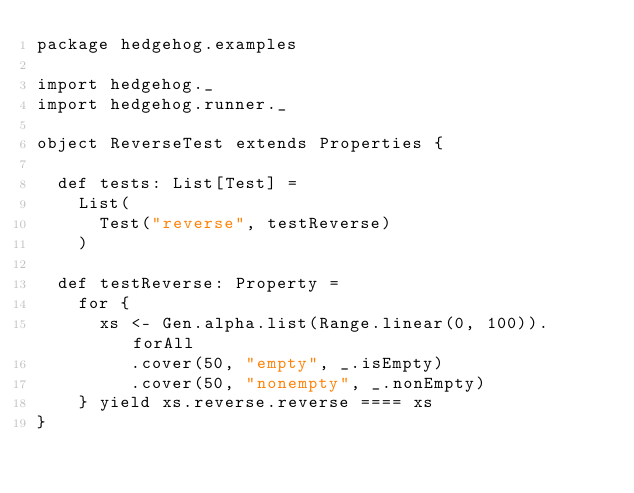<code> <loc_0><loc_0><loc_500><loc_500><_Scala_>package hedgehog.examples

import hedgehog._
import hedgehog.runner._

object ReverseTest extends Properties {

  def tests: List[Test] =
    List(
      Test("reverse", testReverse)
    )

  def testReverse: Property =
    for {
      xs <- Gen.alpha.list(Range.linear(0, 100)).forAll
         .cover(50, "empty", _.isEmpty)
         .cover(50, "nonempty", _.nonEmpty)
    } yield xs.reverse.reverse ==== xs
}
</code> 